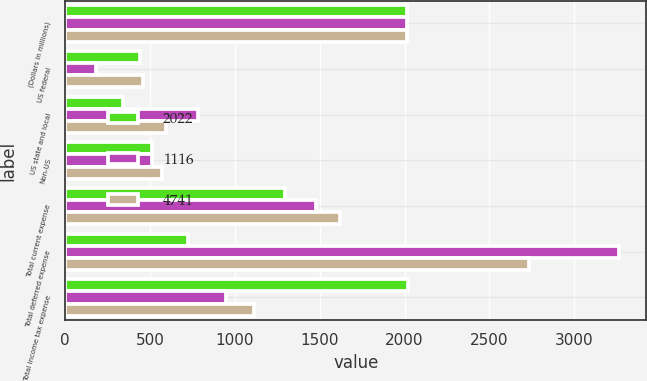<chart> <loc_0><loc_0><loc_500><loc_500><stacked_bar_chart><ecel><fcel>(Dollars in millions)<fcel>US federal<fcel>US state and local<fcel>Non-US<fcel>Total current expense<fcel>Total deferred expense<fcel>Total income tax expense<nl><fcel>2022<fcel>2014<fcel>443<fcel>340<fcel>513<fcel>1296<fcel>726<fcel>2022<nl><fcel>1116<fcel>2013<fcel>180<fcel>786<fcel>513<fcel>1479<fcel>3262<fcel>951<nl><fcel>4741<fcel>2012<fcel>458<fcel>592<fcel>569<fcel>1619<fcel>2735<fcel>1116<nl></chart> 